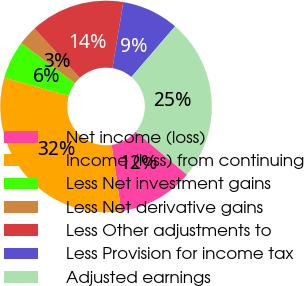<chart> <loc_0><loc_0><loc_500><loc_500><pie_chart><fcel>Net income (loss)<fcel>Income (loss) from continuing<fcel>Less Net investment gains<fcel>Less Net derivative gains<fcel>Less Other adjustments to<fcel>Less Provision for income tax<fcel>Adjusted earnings<nl><fcel>11.57%<fcel>31.67%<fcel>5.83%<fcel>2.96%<fcel>14.44%<fcel>8.7%<fcel>24.83%<nl></chart> 